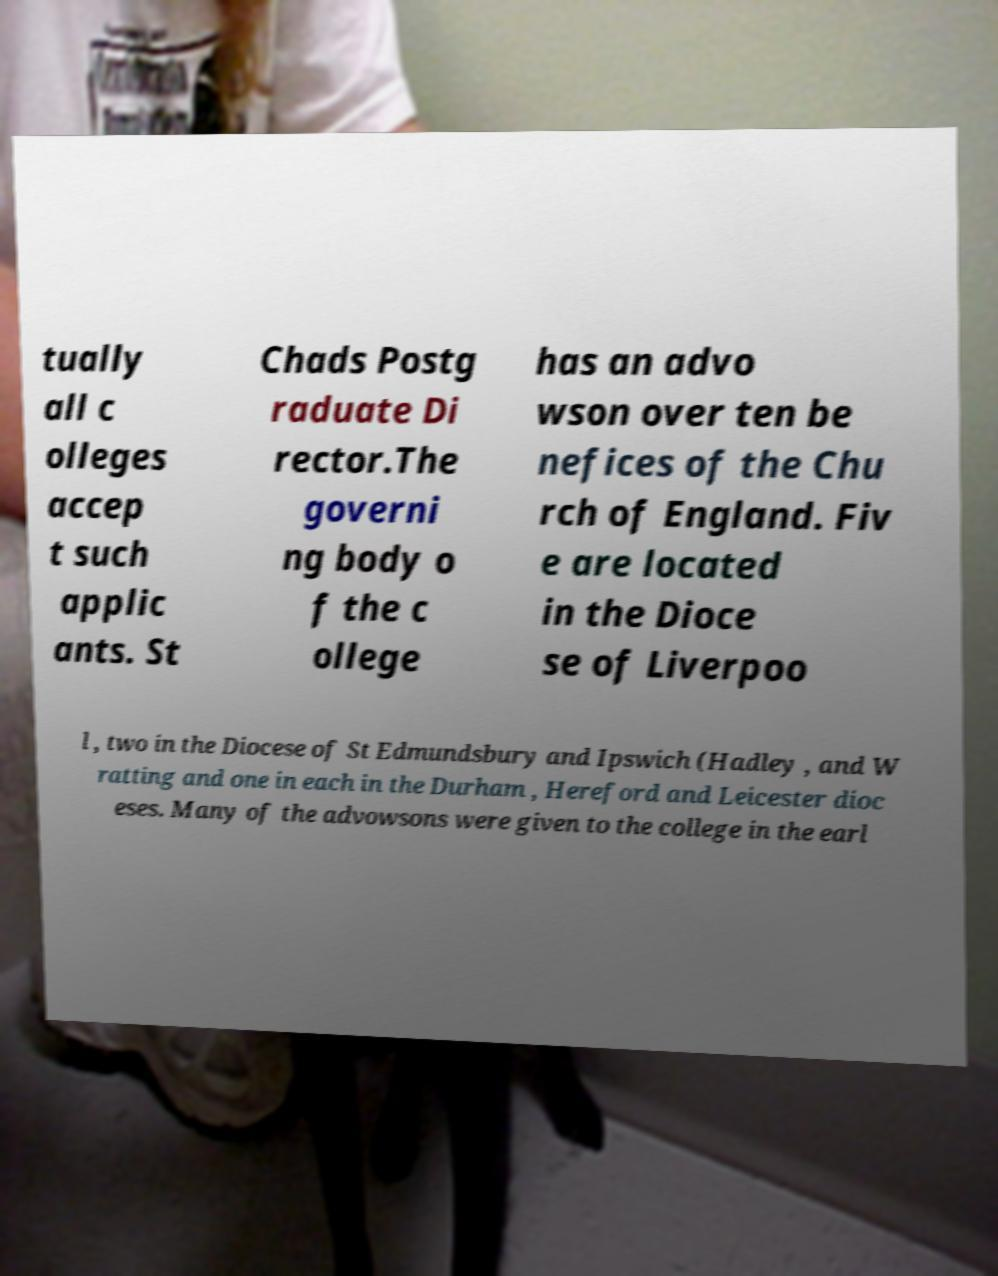Please read and relay the text visible in this image. What does it say? tually all c olleges accep t such applic ants. St Chads Postg raduate Di rector.The governi ng body o f the c ollege has an advo wson over ten be nefices of the Chu rch of England. Fiv e are located in the Dioce se of Liverpoo l , two in the Diocese of St Edmundsbury and Ipswich (Hadley , and W ratting and one in each in the Durham , Hereford and Leicester dioc eses. Many of the advowsons were given to the college in the earl 